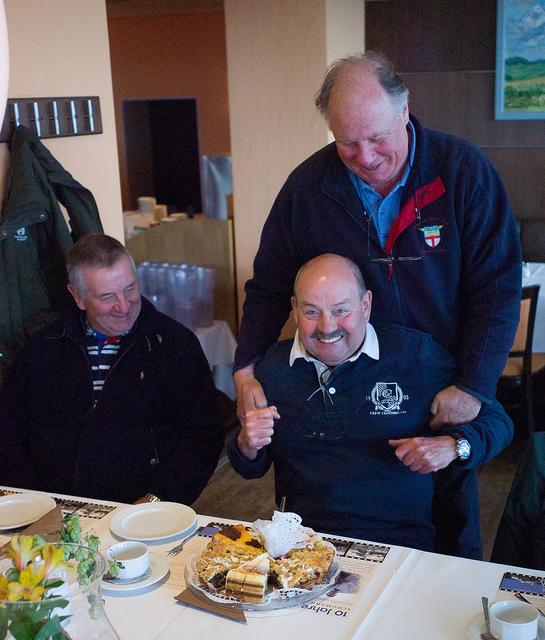Is the man wearing a ring?
Give a very brief answer. No. Did the man just finish his meal?
Give a very brief answer. No. Is this person happy?
Quick response, please. Yes. What is the man eating?
Short answer required. Sandwich. What is the man drinking?
Answer briefly. Coffee. How many men are there?
Be succinct. 3. 